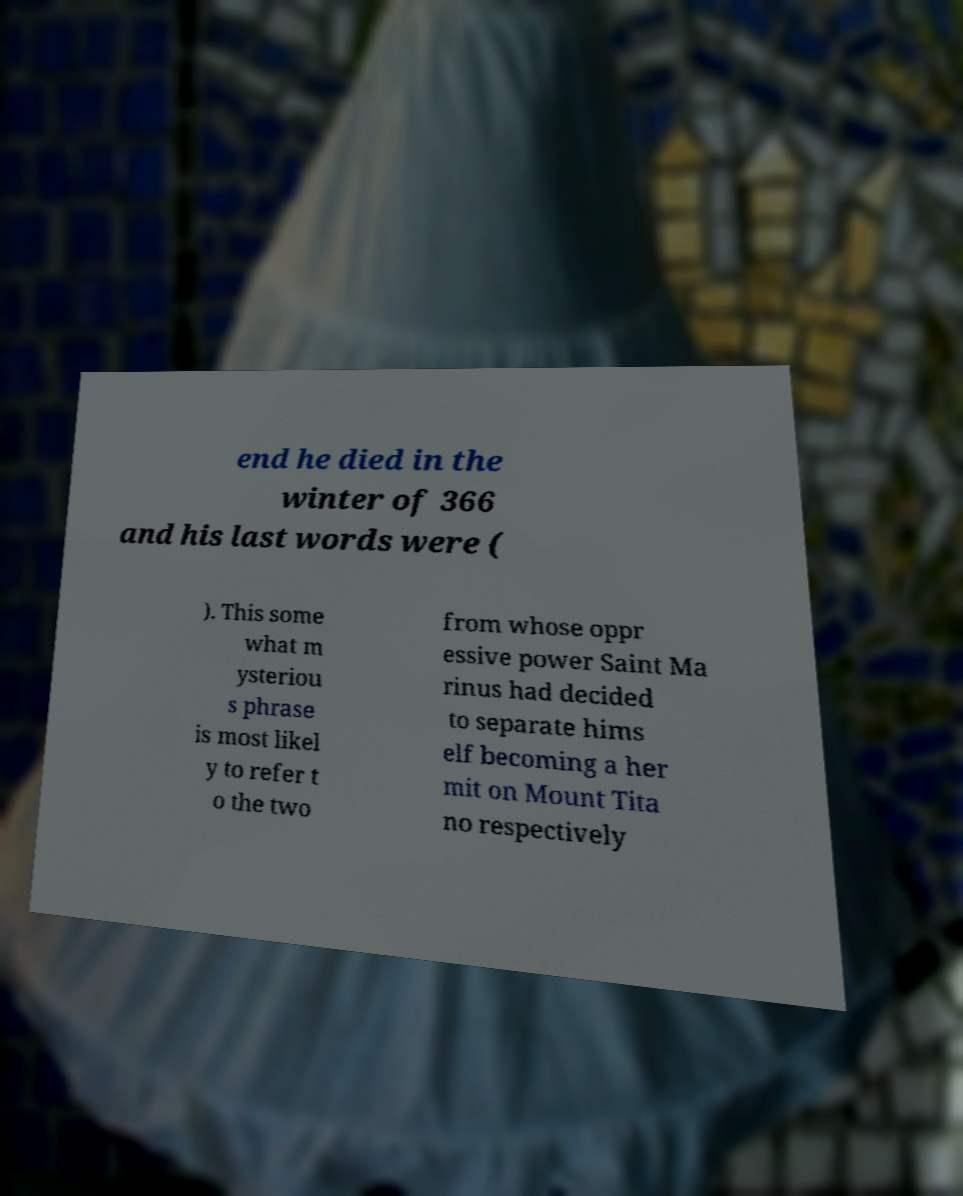Please identify and transcribe the text found in this image. end he died in the winter of 366 and his last words were ( ). This some what m ysteriou s phrase is most likel y to refer t o the two from whose oppr essive power Saint Ma rinus had decided to separate hims elf becoming a her mit on Mount Tita no respectively 